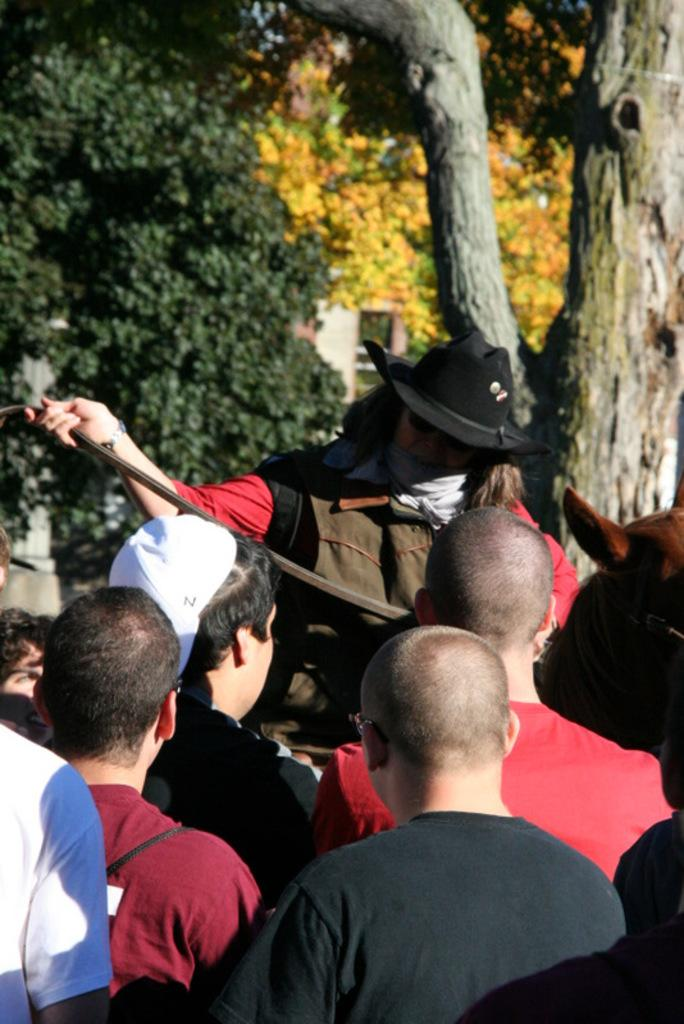Who is the main subject in the image? There is a person in the center of the image. What is the person wearing on their head? The person is wearing a hat. What is the person holding in their hand? The person is holding an object. What can be seen in the distance behind the person? There are trees in the background of the image. Are there any other people visible in the image? Yes, there are some people in the background of the image. What type of reward is the person holding in the image? There is no reward present in the image; the person is holding an object, but its purpose or nature is not specified. 